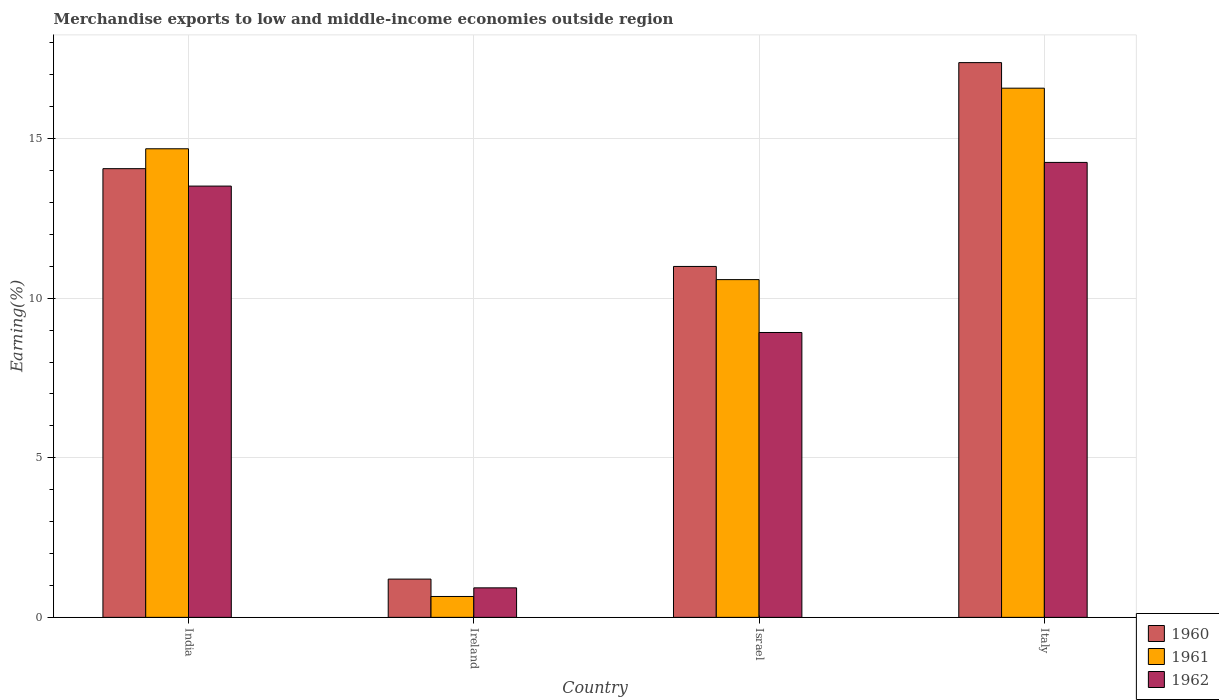Are the number of bars per tick equal to the number of legend labels?
Keep it short and to the point. Yes. Are the number of bars on each tick of the X-axis equal?
Give a very brief answer. Yes. How many bars are there on the 2nd tick from the left?
Provide a succinct answer. 3. What is the label of the 3rd group of bars from the left?
Your response must be concise. Israel. What is the percentage of amount earned from merchandise exports in 1962 in Ireland?
Offer a terse response. 0.92. Across all countries, what is the maximum percentage of amount earned from merchandise exports in 1961?
Keep it short and to the point. 16.58. Across all countries, what is the minimum percentage of amount earned from merchandise exports in 1962?
Your answer should be compact. 0.92. In which country was the percentage of amount earned from merchandise exports in 1960 maximum?
Keep it short and to the point. Italy. In which country was the percentage of amount earned from merchandise exports in 1960 minimum?
Provide a succinct answer. Ireland. What is the total percentage of amount earned from merchandise exports in 1961 in the graph?
Provide a short and direct response. 42.51. What is the difference between the percentage of amount earned from merchandise exports in 1961 in Ireland and that in Italy?
Provide a short and direct response. -15.93. What is the difference between the percentage of amount earned from merchandise exports in 1961 in India and the percentage of amount earned from merchandise exports in 1962 in Italy?
Your response must be concise. 0.43. What is the average percentage of amount earned from merchandise exports in 1960 per country?
Offer a very short reply. 10.91. What is the difference between the percentage of amount earned from merchandise exports of/in 1960 and percentage of amount earned from merchandise exports of/in 1961 in Israel?
Offer a very short reply. 0.41. In how many countries, is the percentage of amount earned from merchandise exports in 1961 greater than 12 %?
Provide a succinct answer. 2. What is the ratio of the percentage of amount earned from merchandise exports in 1960 in India to that in Israel?
Give a very brief answer. 1.28. Is the percentage of amount earned from merchandise exports in 1961 in Ireland less than that in Italy?
Offer a very short reply. Yes. Is the difference between the percentage of amount earned from merchandise exports in 1960 in India and Italy greater than the difference between the percentage of amount earned from merchandise exports in 1961 in India and Italy?
Offer a very short reply. No. What is the difference between the highest and the second highest percentage of amount earned from merchandise exports in 1962?
Your response must be concise. -4.59. What is the difference between the highest and the lowest percentage of amount earned from merchandise exports in 1962?
Keep it short and to the point. 13.33. What does the 1st bar from the right in Italy represents?
Ensure brevity in your answer.  1962. How many bars are there?
Provide a succinct answer. 12. Are all the bars in the graph horizontal?
Ensure brevity in your answer.  No. How many countries are there in the graph?
Ensure brevity in your answer.  4. What is the difference between two consecutive major ticks on the Y-axis?
Your response must be concise. 5. Where does the legend appear in the graph?
Offer a very short reply. Bottom right. How many legend labels are there?
Make the answer very short. 3. What is the title of the graph?
Your answer should be compact. Merchandise exports to low and middle-income economies outside region. Does "1960" appear as one of the legend labels in the graph?
Keep it short and to the point. Yes. What is the label or title of the Y-axis?
Ensure brevity in your answer.  Earning(%). What is the Earning(%) of 1960 in India?
Provide a short and direct response. 14.06. What is the Earning(%) of 1961 in India?
Give a very brief answer. 14.68. What is the Earning(%) in 1962 in India?
Keep it short and to the point. 13.52. What is the Earning(%) of 1960 in Ireland?
Provide a succinct answer. 1.2. What is the Earning(%) in 1961 in Ireland?
Your answer should be compact. 0.65. What is the Earning(%) in 1962 in Ireland?
Make the answer very short. 0.92. What is the Earning(%) of 1960 in Israel?
Give a very brief answer. 11. What is the Earning(%) in 1961 in Israel?
Provide a succinct answer. 10.58. What is the Earning(%) in 1962 in Israel?
Provide a short and direct response. 8.93. What is the Earning(%) in 1960 in Italy?
Provide a succinct answer. 17.38. What is the Earning(%) in 1961 in Italy?
Give a very brief answer. 16.58. What is the Earning(%) in 1962 in Italy?
Your answer should be very brief. 14.26. Across all countries, what is the maximum Earning(%) in 1960?
Make the answer very short. 17.38. Across all countries, what is the maximum Earning(%) of 1961?
Your answer should be very brief. 16.58. Across all countries, what is the maximum Earning(%) in 1962?
Ensure brevity in your answer.  14.26. Across all countries, what is the minimum Earning(%) in 1960?
Give a very brief answer. 1.2. Across all countries, what is the minimum Earning(%) in 1961?
Offer a terse response. 0.65. Across all countries, what is the minimum Earning(%) of 1962?
Your response must be concise. 0.92. What is the total Earning(%) in 1960 in the graph?
Give a very brief answer. 43.64. What is the total Earning(%) of 1961 in the graph?
Ensure brevity in your answer.  42.51. What is the total Earning(%) of 1962 in the graph?
Offer a terse response. 37.63. What is the difference between the Earning(%) of 1960 in India and that in Ireland?
Ensure brevity in your answer.  12.86. What is the difference between the Earning(%) of 1961 in India and that in Ireland?
Provide a short and direct response. 14.03. What is the difference between the Earning(%) of 1962 in India and that in Ireland?
Offer a very short reply. 12.59. What is the difference between the Earning(%) of 1960 in India and that in Israel?
Your response must be concise. 3.06. What is the difference between the Earning(%) of 1961 in India and that in Israel?
Provide a succinct answer. 4.1. What is the difference between the Earning(%) of 1962 in India and that in Israel?
Provide a succinct answer. 4.59. What is the difference between the Earning(%) in 1960 in India and that in Italy?
Give a very brief answer. -3.32. What is the difference between the Earning(%) in 1961 in India and that in Italy?
Your response must be concise. -1.9. What is the difference between the Earning(%) of 1962 in India and that in Italy?
Your response must be concise. -0.74. What is the difference between the Earning(%) of 1960 in Ireland and that in Israel?
Offer a terse response. -9.8. What is the difference between the Earning(%) of 1961 in Ireland and that in Israel?
Your response must be concise. -9.93. What is the difference between the Earning(%) of 1962 in Ireland and that in Israel?
Make the answer very short. -8. What is the difference between the Earning(%) in 1960 in Ireland and that in Italy?
Offer a very short reply. -16.19. What is the difference between the Earning(%) of 1961 in Ireland and that in Italy?
Provide a succinct answer. -15.93. What is the difference between the Earning(%) in 1962 in Ireland and that in Italy?
Your answer should be compact. -13.33. What is the difference between the Earning(%) of 1960 in Israel and that in Italy?
Your response must be concise. -6.39. What is the difference between the Earning(%) of 1961 in Israel and that in Italy?
Give a very brief answer. -6. What is the difference between the Earning(%) of 1962 in Israel and that in Italy?
Your response must be concise. -5.33. What is the difference between the Earning(%) in 1960 in India and the Earning(%) in 1961 in Ireland?
Your answer should be compact. 13.41. What is the difference between the Earning(%) of 1960 in India and the Earning(%) of 1962 in Ireland?
Give a very brief answer. 13.14. What is the difference between the Earning(%) in 1961 in India and the Earning(%) in 1962 in Ireland?
Give a very brief answer. 13.76. What is the difference between the Earning(%) in 1960 in India and the Earning(%) in 1961 in Israel?
Your answer should be very brief. 3.48. What is the difference between the Earning(%) in 1960 in India and the Earning(%) in 1962 in Israel?
Offer a very short reply. 5.13. What is the difference between the Earning(%) in 1961 in India and the Earning(%) in 1962 in Israel?
Offer a terse response. 5.76. What is the difference between the Earning(%) in 1960 in India and the Earning(%) in 1961 in Italy?
Your answer should be very brief. -2.52. What is the difference between the Earning(%) of 1960 in India and the Earning(%) of 1962 in Italy?
Offer a very short reply. -0.2. What is the difference between the Earning(%) of 1961 in India and the Earning(%) of 1962 in Italy?
Offer a very short reply. 0.43. What is the difference between the Earning(%) in 1960 in Ireland and the Earning(%) in 1961 in Israel?
Provide a succinct answer. -9.39. What is the difference between the Earning(%) in 1960 in Ireland and the Earning(%) in 1962 in Israel?
Your response must be concise. -7.73. What is the difference between the Earning(%) in 1961 in Ireland and the Earning(%) in 1962 in Israel?
Offer a very short reply. -8.27. What is the difference between the Earning(%) in 1960 in Ireland and the Earning(%) in 1961 in Italy?
Ensure brevity in your answer.  -15.38. What is the difference between the Earning(%) in 1960 in Ireland and the Earning(%) in 1962 in Italy?
Offer a terse response. -13.06. What is the difference between the Earning(%) in 1961 in Ireland and the Earning(%) in 1962 in Italy?
Provide a short and direct response. -13.6. What is the difference between the Earning(%) of 1960 in Israel and the Earning(%) of 1961 in Italy?
Give a very brief answer. -5.59. What is the difference between the Earning(%) in 1960 in Israel and the Earning(%) in 1962 in Italy?
Provide a short and direct response. -3.26. What is the difference between the Earning(%) of 1961 in Israel and the Earning(%) of 1962 in Italy?
Offer a very short reply. -3.67. What is the average Earning(%) of 1960 per country?
Ensure brevity in your answer.  10.91. What is the average Earning(%) of 1961 per country?
Your answer should be very brief. 10.63. What is the average Earning(%) in 1962 per country?
Provide a succinct answer. 9.41. What is the difference between the Earning(%) in 1960 and Earning(%) in 1961 in India?
Provide a short and direct response. -0.62. What is the difference between the Earning(%) in 1960 and Earning(%) in 1962 in India?
Provide a succinct answer. 0.55. What is the difference between the Earning(%) of 1961 and Earning(%) of 1962 in India?
Keep it short and to the point. 1.17. What is the difference between the Earning(%) of 1960 and Earning(%) of 1961 in Ireland?
Your answer should be compact. 0.54. What is the difference between the Earning(%) in 1960 and Earning(%) in 1962 in Ireland?
Keep it short and to the point. 0.27. What is the difference between the Earning(%) of 1961 and Earning(%) of 1962 in Ireland?
Provide a short and direct response. -0.27. What is the difference between the Earning(%) of 1960 and Earning(%) of 1961 in Israel?
Ensure brevity in your answer.  0.41. What is the difference between the Earning(%) in 1960 and Earning(%) in 1962 in Israel?
Your answer should be compact. 2.07. What is the difference between the Earning(%) of 1961 and Earning(%) of 1962 in Israel?
Make the answer very short. 1.66. What is the difference between the Earning(%) in 1960 and Earning(%) in 1961 in Italy?
Provide a succinct answer. 0.8. What is the difference between the Earning(%) of 1960 and Earning(%) of 1962 in Italy?
Keep it short and to the point. 3.13. What is the difference between the Earning(%) of 1961 and Earning(%) of 1962 in Italy?
Your response must be concise. 2.33. What is the ratio of the Earning(%) of 1960 in India to that in Ireland?
Keep it short and to the point. 11.73. What is the ratio of the Earning(%) of 1961 in India to that in Ireland?
Offer a very short reply. 22.44. What is the ratio of the Earning(%) in 1962 in India to that in Ireland?
Offer a terse response. 14.61. What is the ratio of the Earning(%) in 1960 in India to that in Israel?
Ensure brevity in your answer.  1.28. What is the ratio of the Earning(%) in 1961 in India to that in Israel?
Ensure brevity in your answer.  1.39. What is the ratio of the Earning(%) of 1962 in India to that in Israel?
Provide a succinct answer. 1.51. What is the ratio of the Earning(%) in 1960 in India to that in Italy?
Give a very brief answer. 0.81. What is the ratio of the Earning(%) of 1961 in India to that in Italy?
Keep it short and to the point. 0.89. What is the ratio of the Earning(%) of 1962 in India to that in Italy?
Your answer should be compact. 0.95. What is the ratio of the Earning(%) of 1960 in Ireland to that in Israel?
Offer a terse response. 0.11. What is the ratio of the Earning(%) in 1961 in Ireland to that in Israel?
Your answer should be very brief. 0.06. What is the ratio of the Earning(%) of 1962 in Ireland to that in Israel?
Keep it short and to the point. 0.1. What is the ratio of the Earning(%) of 1960 in Ireland to that in Italy?
Your answer should be compact. 0.07. What is the ratio of the Earning(%) in 1961 in Ireland to that in Italy?
Make the answer very short. 0.04. What is the ratio of the Earning(%) in 1962 in Ireland to that in Italy?
Give a very brief answer. 0.06. What is the ratio of the Earning(%) in 1960 in Israel to that in Italy?
Keep it short and to the point. 0.63. What is the ratio of the Earning(%) of 1961 in Israel to that in Italy?
Ensure brevity in your answer.  0.64. What is the ratio of the Earning(%) of 1962 in Israel to that in Italy?
Give a very brief answer. 0.63. What is the difference between the highest and the second highest Earning(%) in 1960?
Your response must be concise. 3.32. What is the difference between the highest and the second highest Earning(%) in 1961?
Offer a very short reply. 1.9. What is the difference between the highest and the second highest Earning(%) of 1962?
Ensure brevity in your answer.  0.74. What is the difference between the highest and the lowest Earning(%) in 1960?
Provide a succinct answer. 16.19. What is the difference between the highest and the lowest Earning(%) of 1961?
Offer a very short reply. 15.93. What is the difference between the highest and the lowest Earning(%) of 1962?
Give a very brief answer. 13.33. 